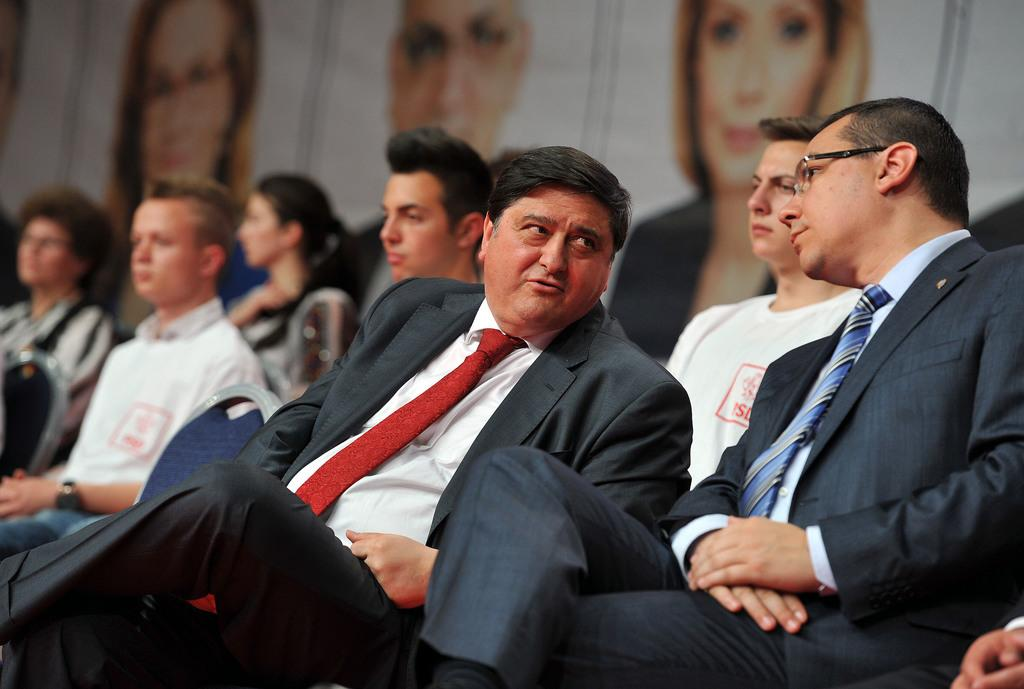What is the main subject of the image? The main subject of the image is a group of people. Can you describe the men in the foreground? In the foreground, there are three men, and one of them is talking. How is the background of the people depicted in the image? The background of the people is blurry. What type of beef is being served at the birth of the relation in the image? There is no mention of a birth, relation, or beef in the image; it features a group of people with a talking man in the foreground and a blurry background. 